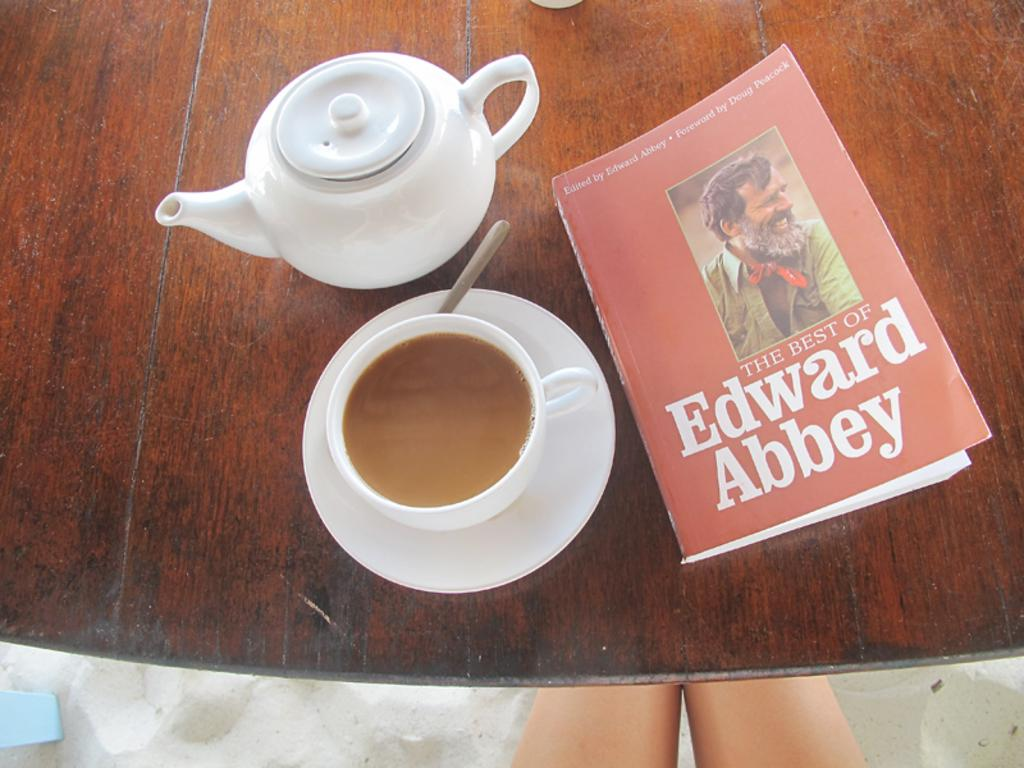<image>
Share a concise interpretation of the image provided. My perfect morning at the beach, coffee and The Best of Edward Abbey 